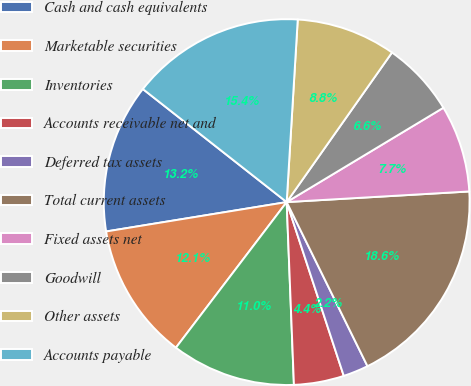Convert chart to OTSL. <chart><loc_0><loc_0><loc_500><loc_500><pie_chart><fcel>Cash and cash equivalents<fcel>Marketable securities<fcel>Inventories<fcel>Accounts receivable net and<fcel>Deferred tax assets<fcel>Total current assets<fcel>Fixed assets net<fcel>Goodwill<fcel>Other assets<fcel>Accounts payable<nl><fcel>13.17%<fcel>12.08%<fcel>10.98%<fcel>4.42%<fcel>2.23%<fcel>18.64%<fcel>7.7%<fcel>6.61%<fcel>8.8%<fcel>15.36%<nl></chart> 